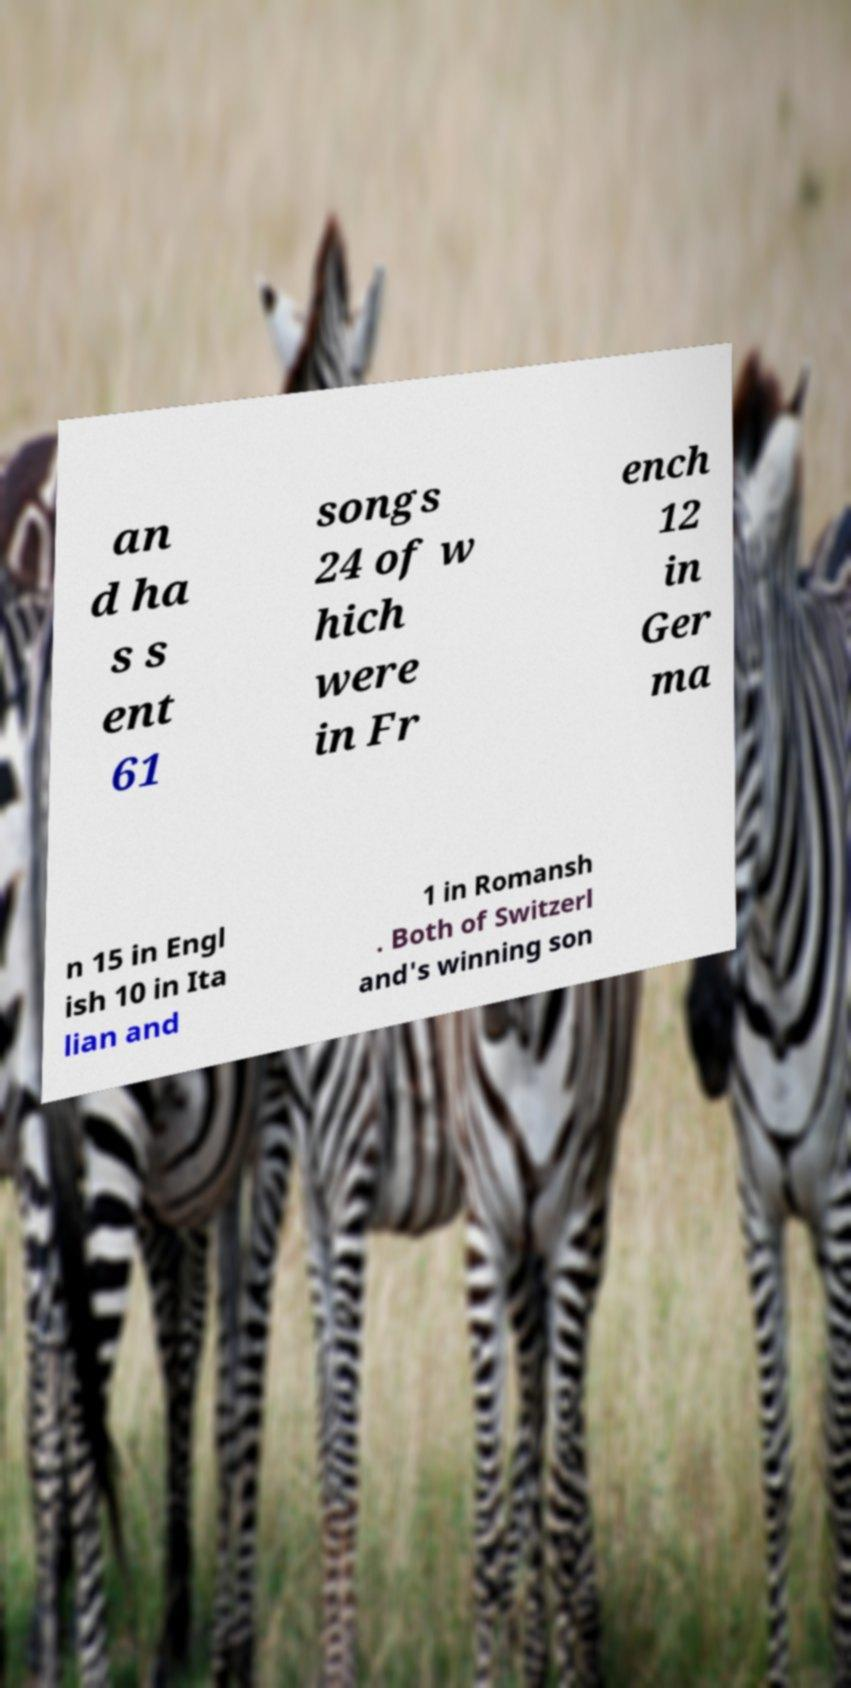Can you accurately transcribe the text from the provided image for me? an d ha s s ent 61 songs 24 of w hich were in Fr ench 12 in Ger ma n 15 in Engl ish 10 in Ita lian and 1 in Romansh . Both of Switzerl and's winning son 